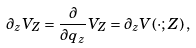<formula> <loc_0><loc_0><loc_500><loc_500>\partial _ { z } V _ { Z } = \frac { \partial } { \partial q _ { z } } V _ { Z } = \partial _ { z } V ( \cdot ; Z ) \, ,</formula> 